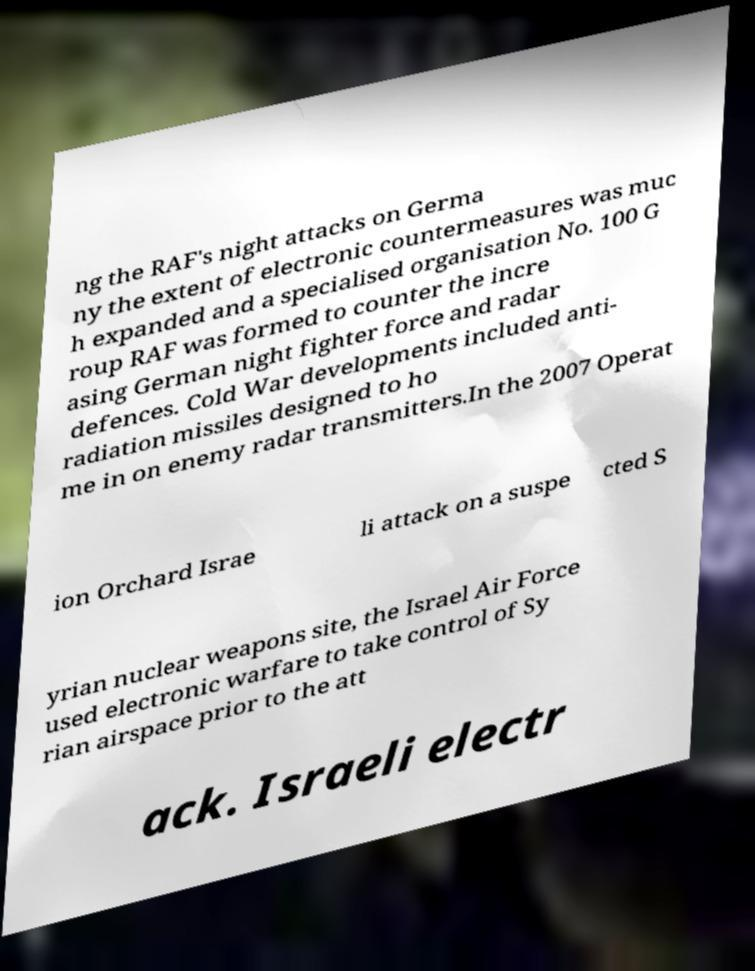Could you extract and type out the text from this image? ng the RAF's night attacks on Germa ny the extent of electronic countermeasures was muc h expanded and a specialised organisation No. 100 G roup RAF was formed to counter the incre asing German night fighter force and radar defences. Cold War developments included anti- radiation missiles designed to ho me in on enemy radar transmitters.In the 2007 Operat ion Orchard Israe li attack on a suspe cted S yrian nuclear weapons site, the Israel Air Force used electronic warfare to take control of Sy rian airspace prior to the att ack. Israeli electr 